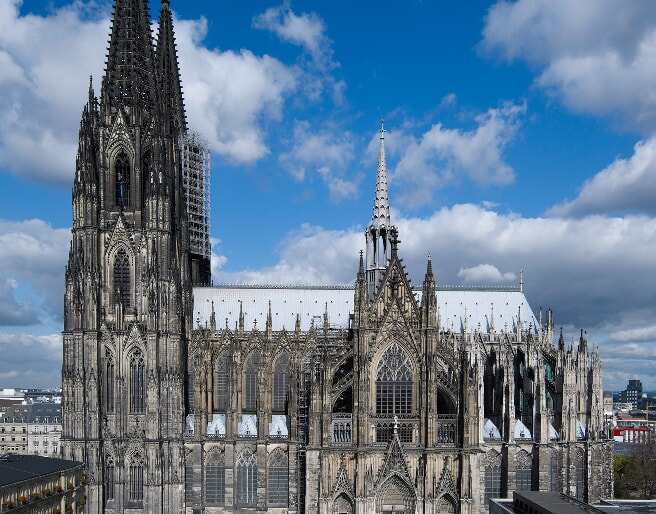What can you tell me about the historical significance of the Cologne Cathedral? The Cologne Cathedral, also known as Kölner Dom, is an iconic symbol of Gothic architecture and an integral part of Germany’s cultural heritage. It was officially commenced in 1248 but wasn't completed until 1880, spanning over six centuries, during which its construction was halted several times. Initially conceived to house the relics of the Three Kings, which were brought to Cologne in 1164, the cathedral became a pilgrimage site. Its construction symbolizes the enduring faith and dedication of generations. The cathedral also miraculously survived the extensive bombings during World War II, with only minor damages, standing as a beacon of resilience. Today, it is not only a place of worship but a UNESCO World Heritage site that attracts millions of visitors yearly for its spiritual, historical, and architectural significance. What are some unique architectural features of the Cologne Cathedral? Cologne Cathedral is renowned for several unique architectural features. Its twin spires, standing at approximately 157 meters, were the tallest structures in the world until the late 19th century and remain the tallest twin-spired church towers in the world today. The facade is adorned with intricate carvings and sculptures, characteristic of Gothic architecture. Flying buttresses provide structural support while also adding to its aesthetic appeal. Inside, visitors can admire the stunning stained-glass windows, particularly the immense multi-colored window in the southern transept, which presents a striking kaleidoscope of biblical scenes. The cathedral also houses the Shrine of the Three Kings, an ornate reliquary purported to contain the bones of the Biblical Magi. The unique blend of art, architecture, and history makes Cologne Cathedral a masterpiece of medieval craftsmanship. 